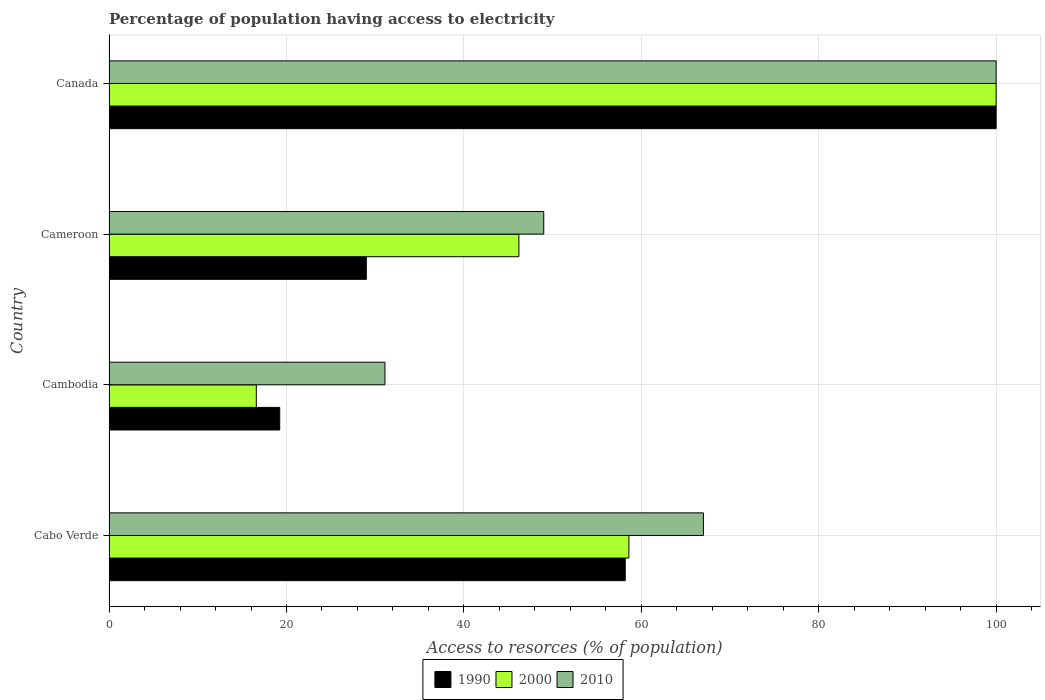Are the number of bars on each tick of the Y-axis equal?
Offer a terse response. Yes. How many bars are there on the 1st tick from the top?
Provide a succinct answer. 3. How many bars are there on the 4th tick from the bottom?
Your response must be concise. 3. What is the label of the 2nd group of bars from the top?
Ensure brevity in your answer.  Cameroon. What is the percentage of population having access to electricity in 2010 in Cambodia?
Provide a short and direct response. 31.1. Across all countries, what is the maximum percentage of population having access to electricity in 2010?
Offer a very short reply. 100. In which country was the percentage of population having access to electricity in 2010 minimum?
Your response must be concise. Cambodia. What is the total percentage of population having access to electricity in 2000 in the graph?
Your answer should be very brief. 221.4. What is the difference between the percentage of population having access to electricity in 2010 in Cameroon and that in Canada?
Provide a succinct answer. -51. What is the difference between the percentage of population having access to electricity in 2010 in Cabo Verde and the percentage of population having access to electricity in 2000 in Cambodia?
Keep it short and to the point. 50.4. What is the average percentage of population having access to electricity in 2000 per country?
Provide a short and direct response. 55.35. What is the difference between the percentage of population having access to electricity in 2010 and percentage of population having access to electricity in 1990 in Cambodia?
Offer a terse response. 11.86. What is the ratio of the percentage of population having access to electricity in 2000 in Cabo Verde to that in Cameroon?
Provide a short and direct response. 1.27. Is the percentage of population having access to electricity in 2010 in Cabo Verde less than that in Cameroon?
Make the answer very short. No. Is the difference between the percentage of population having access to electricity in 2010 in Cameroon and Canada greater than the difference between the percentage of population having access to electricity in 1990 in Cameroon and Canada?
Provide a succinct answer. Yes. What is the difference between the highest and the second highest percentage of population having access to electricity in 2010?
Your response must be concise. 33. What is the difference between the highest and the lowest percentage of population having access to electricity in 2010?
Ensure brevity in your answer.  68.9. In how many countries, is the percentage of population having access to electricity in 2000 greater than the average percentage of population having access to electricity in 2000 taken over all countries?
Give a very brief answer. 2. Is it the case that in every country, the sum of the percentage of population having access to electricity in 2010 and percentage of population having access to electricity in 1990 is greater than the percentage of population having access to electricity in 2000?
Give a very brief answer. Yes. Are all the bars in the graph horizontal?
Keep it short and to the point. Yes. How many countries are there in the graph?
Offer a very short reply. 4. What is the difference between two consecutive major ticks on the X-axis?
Your answer should be compact. 20. Are the values on the major ticks of X-axis written in scientific E-notation?
Ensure brevity in your answer.  No. Does the graph contain any zero values?
Give a very brief answer. No. What is the title of the graph?
Provide a succinct answer. Percentage of population having access to electricity. What is the label or title of the X-axis?
Keep it short and to the point. Access to resorces (% of population). What is the Access to resorces (% of population) in 1990 in Cabo Verde?
Provide a succinct answer. 58.19. What is the Access to resorces (% of population) of 2000 in Cabo Verde?
Make the answer very short. 58.6. What is the Access to resorces (% of population) in 2010 in Cabo Verde?
Ensure brevity in your answer.  67. What is the Access to resorces (% of population) of 1990 in Cambodia?
Make the answer very short. 19.24. What is the Access to resorces (% of population) in 2000 in Cambodia?
Your answer should be very brief. 16.6. What is the Access to resorces (% of population) in 2010 in Cambodia?
Offer a terse response. 31.1. What is the Access to resorces (% of population) in 2000 in Cameroon?
Give a very brief answer. 46.2. Across all countries, what is the maximum Access to resorces (% of population) in 2000?
Provide a succinct answer. 100. Across all countries, what is the minimum Access to resorces (% of population) of 1990?
Your answer should be compact. 19.24. Across all countries, what is the minimum Access to resorces (% of population) in 2010?
Offer a terse response. 31.1. What is the total Access to resorces (% of population) of 1990 in the graph?
Offer a very short reply. 206.43. What is the total Access to resorces (% of population) in 2000 in the graph?
Keep it short and to the point. 221.4. What is the total Access to resorces (% of population) of 2010 in the graph?
Your response must be concise. 247.1. What is the difference between the Access to resorces (% of population) in 1990 in Cabo Verde and that in Cambodia?
Provide a succinct answer. 38.95. What is the difference between the Access to resorces (% of population) of 2000 in Cabo Verde and that in Cambodia?
Offer a very short reply. 42. What is the difference between the Access to resorces (% of population) of 2010 in Cabo Verde and that in Cambodia?
Provide a succinct answer. 35.9. What is the difference between the Access to resorces (% of population) of 1990 in Cabo Verde and that in Cameroon?
Your response must be concise. 29.19. What is the difference between the Access to resorces (% of population) of 2010 in Cabo Verde and that in Cameroon?
Your answer should be compact. 18. What is the difference between the Access to resorces (% of population) of 1990 in Cabo Verde and that in Canada?
Offer a very short reply. -41.81. What is the difference between the Access to resorces (% of population) in 2000 in Cabo Verde and that in Canada?
Make the answer very short. -41.4. What is the difference between the Access to resorces (% of population) in 2010 in Cabo Verde and that in Canada?
Offer a very short reply. -33. What is the difference between the Access to resorces (% of population) in 1990 in Cambodia and that in Cameroon?
Offer a terse response. -9.76. What is the difference between the Access to resorces (% of population) of 2000 in Cambodia and that in Cameroon?
Your answer should be very brief. -29.6. What is the difference between the Access to resorces (% of population) in 2010 in Cambodia and that in Cameroon?
Ensure brevity in your answer.  -17.9. What is the difference between the Access to resorces (% of population) in 1990 in Cambodia and that in Canada?
Make the answer very short. -80.76. What is the difference between the Access to resorces (% of population) of 2000 in Cambodia and that in Canada?
Offer a terse response. -83.4. What is the difference between the Access to resorces (% of population) in 2010 in Cambodia and that in Canada?
Make the answer very short. -68.9. What is the difference between the Access to resorces (% of population) in 1990 in Cameroon and that in Canada?
Offer a very short reply. -71. What is the difference between the Access to resorces (% of population) in 2000 in Cameroon and that in Canada?
Your response must be concise. -53.8. What is the difference between the Access to resorces (% of population) in 2010 in Cameroon and that in Canada?
Ensure brevity in your answer.  -51. What is the difference between the Access to resorces (% of population) of 1990 in Cabo Verde and the Access to resorces (% of population) of 2000 in Cambodia?
Ensure brevity in your answer.  41.59. What is the difference between the Access to resorces (% of population) of 1990 in Cabo Verde and the Access to resorces (% of population) of 2010 in Cambodia?
Keep it short and to the point. 27.09. What is the difference between the Access to resorces (% of population) in 2000 in Cabo Verde and the Access to resorces (% of population) in 2010 in Cambodia?
Ensure brevity in your answer.  27.5. What is the difference between the Access to resorces (% of population) of 1990 in Cabo Verde and the Access to resorces (% of population) of 2000 in Cameroon?
Your answer should be compact. 11.99. What is the difference between the Access to resorces (% of population) in 1990 in Cabo Verde and the Access to resorces (% of population) in 2010 in Cameroon?
Offer a very short reply. 9.19. What is the difference between the Access to resorces (% of population) of 2000 in Cabo Verde and the Access to resorces (% of population) of 2010 in Cameroon?
Offer a terse response. 9.6. What is the difference between the Access to resorces (% of population) of 1990 in Cabo Verde and the Access to resorces (% of population) of 2000 in Canada?
Your answer should be very brief. -41.81. What is the difference between the Access to resorces (% of population) in 1990 in Cabo Verde and the Access to resorces (% of population) in 2010 in Canada?
Your answer should be compact. -41.81. What is the difference between the Access to resorces (% of population) in 2000 in Cabo Verde and the Access to resorces (% of population) in 2010 in Canada?
Make the answer very short. -41.4. What is the difference between the Access to resorces (% of population) of 1990 in Cambodia and the Access to resorces (% of population) of 2000 in Cameroon?
Provide a short and direct response. -26.96. What is the difference between the Access to resorces (% of population) in 1990 in Cambodia and the Access to resorces (% of population) in 2010 in Cameroon?
Ensure brevity in your answer.  -29.76. What is the difference between the Access to resorces (% of population) in 2000 in Cambodia and the Access to resorces (% of population) in 2010 in Cameroon?
Keep it short and to the point. -32.4. What is the difference between the Access to resorces (% of population) in 1990 in Cambodia and the Access to resorces (% of population) in 2000 in Canada?
Provide a succinct answer. -80.76. What is the difference between the Access to resorces (% of population) of 1990 in Cambodia and the Access to resorces (% of population) of 2010 in Canada?
Your answer should be compact. -80.76. What is the difference between the Access to resorces (% of population) in 2000 in Cambodia and the Access to resorces (% of population) in 2010 in Canada?
Provide a succinct answer. -83.4. What is the difference between the Access to resorces (% of population) in 1990 in Cameroon and the Access to resorces (% of population) in 2000 in Canada?
Your answer should be very brief. -71. What is the difference between the Access to resorces (% of population) of 1990 in Cameroon and the Access to resorces (% of population) of 2010 in Canada?
Provide a short and direct response. -71. What is the difference between the Access to resorces (% of population) of 2000 in Cameroon and the Access to resorces (% of population) of 2010 in Canada?
Give a very brief answer. -53.8. What is the average Access to resorces (% of population) of 1990 per country?
Ensure brevity in your answer.  51.61. What is the average Access to resorces (% of population) in 2000 per country?
Your answer should be very brief. 55.35. What is the average Access to resorces (% of population) in 2010 per country?
Your answer should be compact. 61.77. What is the difference between the Access to resorces (% of population) of 1990 and Access to resorces (% of population) of 2000 in Cabo Verde?
Give a very brief answer. -0.41. What is the difference between the Access to resorces (% of population) of 1990 and Access to resorces (% of population) of 2010 in Cabo Verde?
Offer a terse response. -8.81. What is the difference between the Access to resorces (% of population) in 1990 and Access to resorces (% of population) in 2000 in Cambodia?
Ensure brevity in your answer.  2.64. What is the difference between the Access to resorces (% of population) of 1990 and Access to resorces (% of population) of 2010 in Cambodia?
Offer a very short reply. -11.86. What is the difference between the Access to resorces (% of population) of 1990 and Access to resorces (% of population) of 2000 in Cameroon?
Keep it short and to the point. -17.2. What is the difference between the Access to resorces (% of population) in 1990 and Access to resorces (% of population) in 2010 in Cameroon?
Make the answer very short. -20. What is the difference between the Access to resorces (% of population) in 1990 and Access to resorces (% of population) in 2010 in Canada?
Your response must be concise. 0. What is the difference between the Access to resorces (% of population) in 2000 and Access to resorces (% of population) in 2010 in Canada?
Provide a short and direct response. 0. What is the ratio of the Access to resorces (% of population) in 1990 in Cabo Verde to that in Cambodia?
Your answer should be compact. 3.02. What is the ratio of the Access to resorces (% of population) in 2000 in Cabo Verde to that in Cambodia?
Give a very brief answer. 3.53. What is the ratio of the Access to resorces (% of population) of 2010 in Cabo Verde to that in Cambodia?
Offer a terse response. 2.15. What is the ratio of the Access to resorces (% of population) of 1990 in Cabo Verde to that in Cameroon?
Provide a short and direct response. 2.01. What is the ratio of the Access to resorces (% of population) of 2000 in Cabo Verde to that in Cameroon?
Ensure brevity in your answer.  1.27. What is the ratio of the Access to resorces (% of population) in 2010 in Cabo Verde to that in Cameroon?
Your answer should be very brief. 1.37. What is the ratio of the Access to resorces (% of population) in 1990 in Cabo Verde to that in Canada?
Your answer should be compact. 0.58. What is the ratio of the Access to resorces (% of population) of 2000 in Cabo Verde to that in Canada?
Provide a succinct answer. 0.59. What is the ratio of the Access to resorces (% of population) in 2010 in Cabo Verde to that in Canada?
Offer a terse response. 0.67. What is the ratio of the Access to resorces (% of population) in 1990 in Cambodia to that in Cameroon?
Give a very brief answer. 0.66. What is the ratio of the Access to resorces (% of population) in 2000 in Cambodia to that in Cameroon?
Your response must be concise. 0.36. What is the ratio of the Access to resorces (% of population) of 2010 in Cambodia to that in Cameroon?
Your response must be concise. 0.63. What is the ratio of the Access to resorces (% of population) of 1990 in Cambodia to that in Canada?
Offer a very short reply. 0.19. What is the ratio of the Access to resorces (% of population) in 2000 in Cambodia to that in Canada?
Your response must be concise. 0.17. What is the ratio of the Access to resorces (% of population) of 2010 in Cambodia to that in Canada?
Your answer should be very brief. 0.31. What is the ratio of the Access to resorces (% of population) in 1990 in Cameroon to that in Canada?
Your answer should be very brief. 0.29. What is the ratio of the Access to resorces (% of population) of 2000 in Cameroon to that in Canada?
Provide a short and direct response. 0.46. What is the ratio of the Access to resorces (% of population) of 2010 in Cameroon to that in Canada?
Your response must be concise. 0.49. What is the difference between the highest and the second highest Access to resorces (% of population) of 1990?
Offer a terse response. 41.81. What is the difference between the highest and the second highest Access to resorces (% of population) of 2000?
Provide a short and direct response. 41.4. What is the difference between the highest and the second highest Access to resorces (% of population) in 2010?
Your response must be concise. 33. What is the difference between the highest and the lowest Access to resorces (% of population) in 1990?
Give a very brief answer. 80.76. What is the difference between the highest and the lowest Access to resorces (% of population) in 2000?
Offer a very short reply. 83.4. What is the difference between the highest and the lowest Access to resorces (% of population) in 2010?
Ensure brevity in your answer.  68.9. 